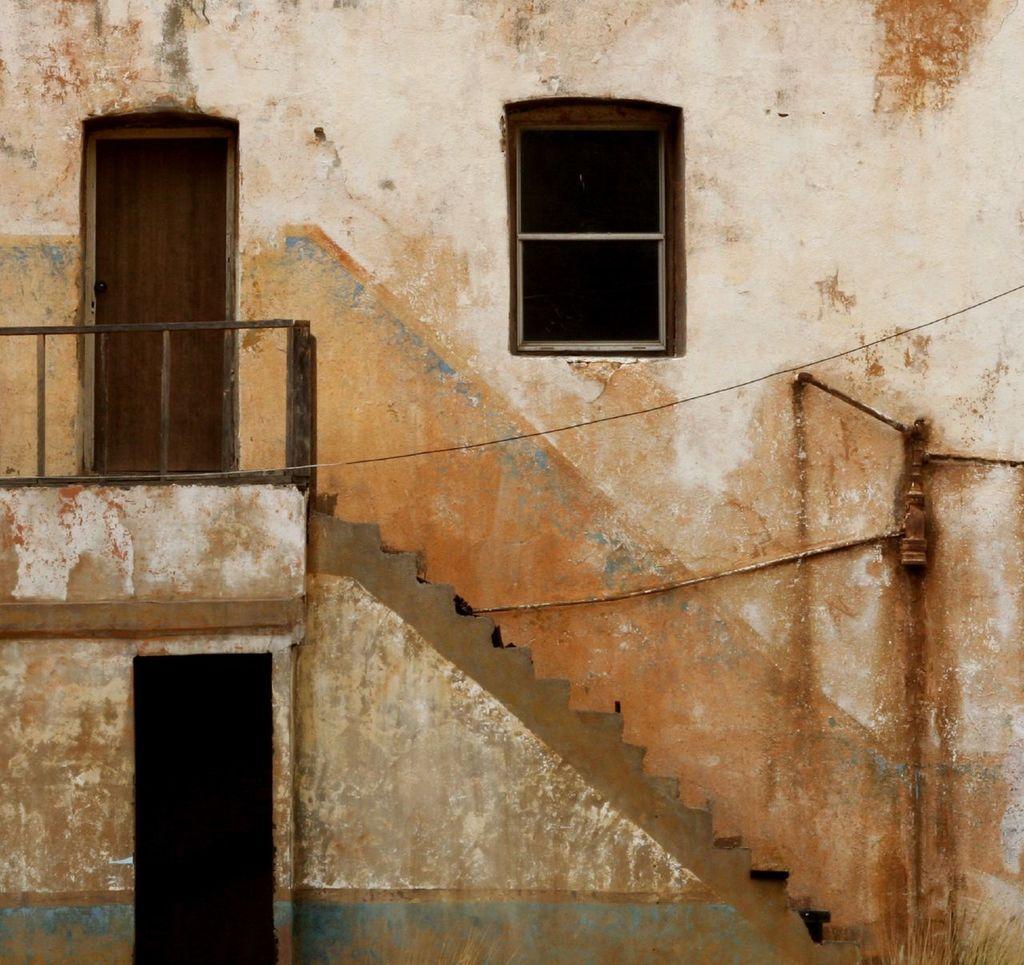In one or two sentences, can you explain what this image depicts? This is a picture of the building , where there are iron grills, staircase, door, window. 